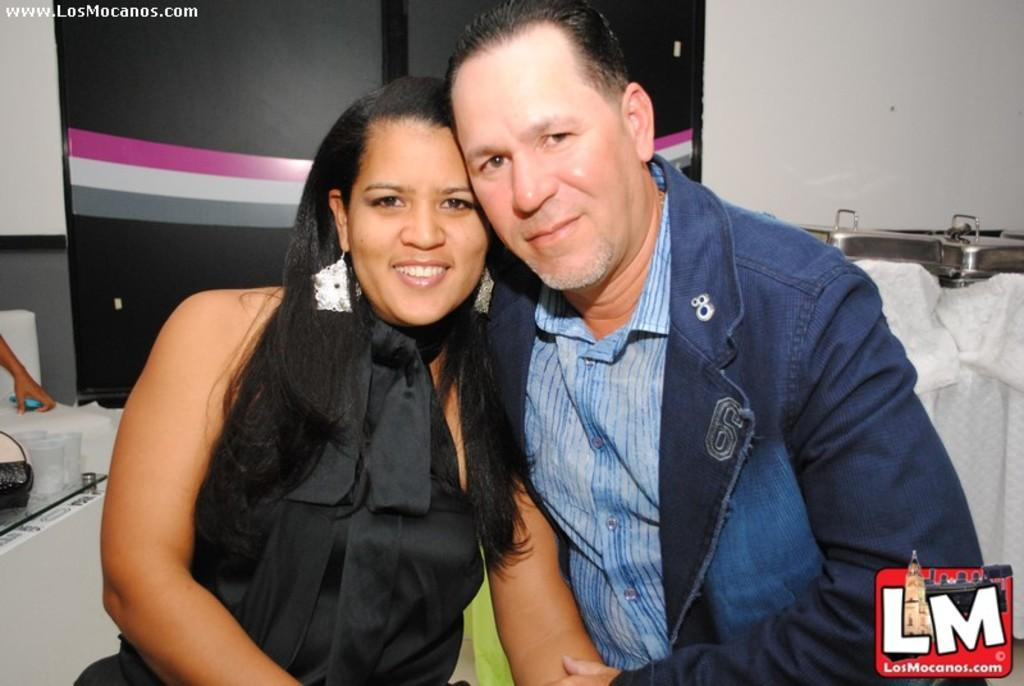Who are the people in the image? There is a man and a woman in the image. Where are the man and woman located in the image? The man and woman are in the center of the image. What can be seen in the background of the image? There is a poster in the background of the image. What type of test is being conducted in the image? There is no test being conducted in the image; it features a man and a woman in the center with a poster in the background. What meal is being prepared in the image? There is no meal preparation visible in the image. 